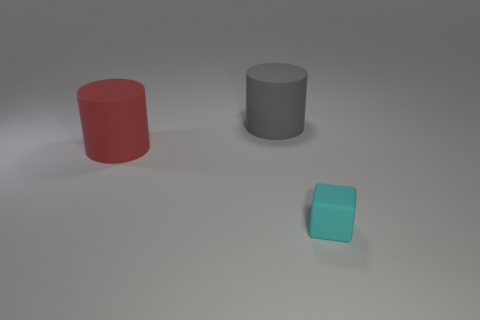Is the shape of the gray matte thing the same as the large thing that is on the left side of the big gray cylinder?
Your answer should be very brief. Yes. What size is the matte thing that is in front of the big gray cylinder and on the right side of the red thing?
Your answer should be compact. Small. Is there a cyan block that has the same material as the big red thing?
Your answer should be very brief. Yes. The cube that is made of the same material as the big gray object is what size?
Provide a succinct answer. Small. There is a rubber thing in front of the large red cylinder; what is its shape?
Your answer should be compact. Cube. There is another rubber thing that is the same shape as the large gray rubber thing; what is its size?
Your answer should be compact. Large. How many large cylinders are on the right side of the big matte thing to the right of the large rubber object in front of the big gray rubber cylinder?
Provide a short and direct response. 0. Are there the same number of cyan rubber objects that are on the right side of the small cube and green things?
Your answer should be compact. Yes. How many spheres are red rubber things or small cyan objects?
Offer a terse response. 0. Is the number of large gray cylinders in front of the large red thing the same as the number of matte things that are in front of the cyan rubber cube?
Keep it short and to the point. Yes. 